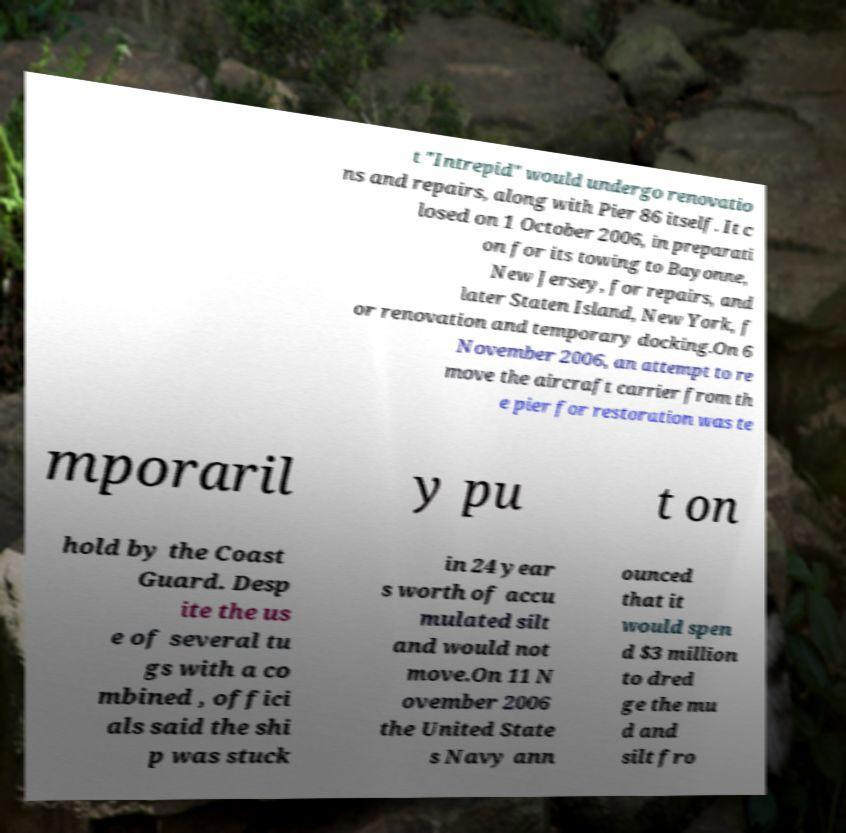Can you accurately transcribe the text from the provided image for me? t "Intrepid" would undergo renovatio ns and repairs, along with Pier 86 itself. It c losed on 1 October 2006, in preparati on for its towing to Bayonne, New Jersey, for repairs, and later Staten Island, New York, f or renovation and temporary docking.On 6 November 2006, an attempt to re move the aircraft carrier from th e pier for restoration was te mporaril y pu t on hold by the Coast Guard. Desp ite the us e of several tu gs with a co mbined , offici als said the shi p was stuck in 24 year s worth of accu mulated silt and would not move.On 11 N ovember 2006 the United State s Navy ann ounced that it would spen d $3 million to dred ge the mu d and silt fro 